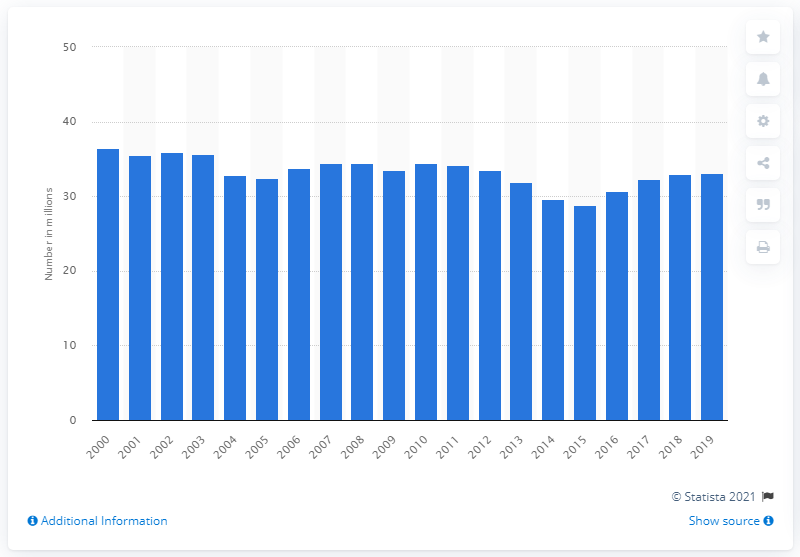Give some essential details in this illustration. In 2015, a total of 28.8 million cattle were slaughtered in the United States. 